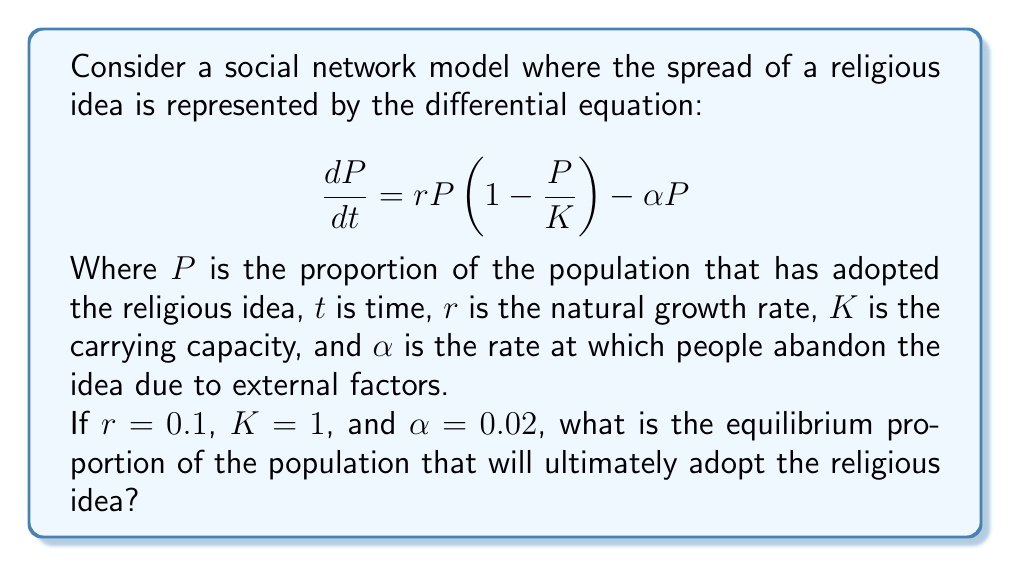Solve this math problem. To find the equilibrium proportion, we need to solve for $P$ when $\frac{dP}{dt} = 0$:

1) Set the equation equal to zero:
   $$0 = rP(1-\frac{P}{K}) - \alpha P$$

2) Substitute the given values:
   $$0 = 0.1P(1-P) - 0.02P$$

3) Expand the equation:
   $$0 = 0.1P - 0.1P^2 - 0.02P$$

4) Simplify:
   $$0 = 0.08P - 0.1P^2$$

5) Factor out P:
   $$P(0.08 - 0.1P) = 0$$

6) Solve for P:
   Either $P = 0$ or $0.08 - 0.1P = 0$

7) For the non-zero solution:
   $$0.08 = 0.1P$$
   $$P = 0.08 / 0.1 = 0.8$$

8) Check stability:
   The solution $P = 0$ is unstable, while $P = 0.8$ is stable.

Therefore, the equilibrium proportion is 0.8 or 80% of the population.
Answer: 0.8 